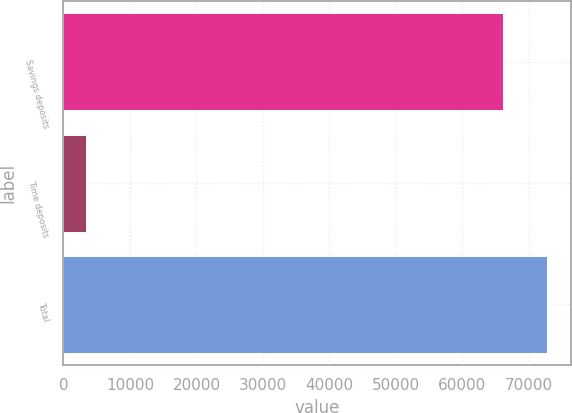Convert chart. <chart><loc_0><loc_0><loc_500><loc_500><bar_chart><fcel>Savings deposits<fcel>Time deposits<fcel>Total<nl><fcel>66073<fcel>3357<fcel>72680.3<nl></chart> 